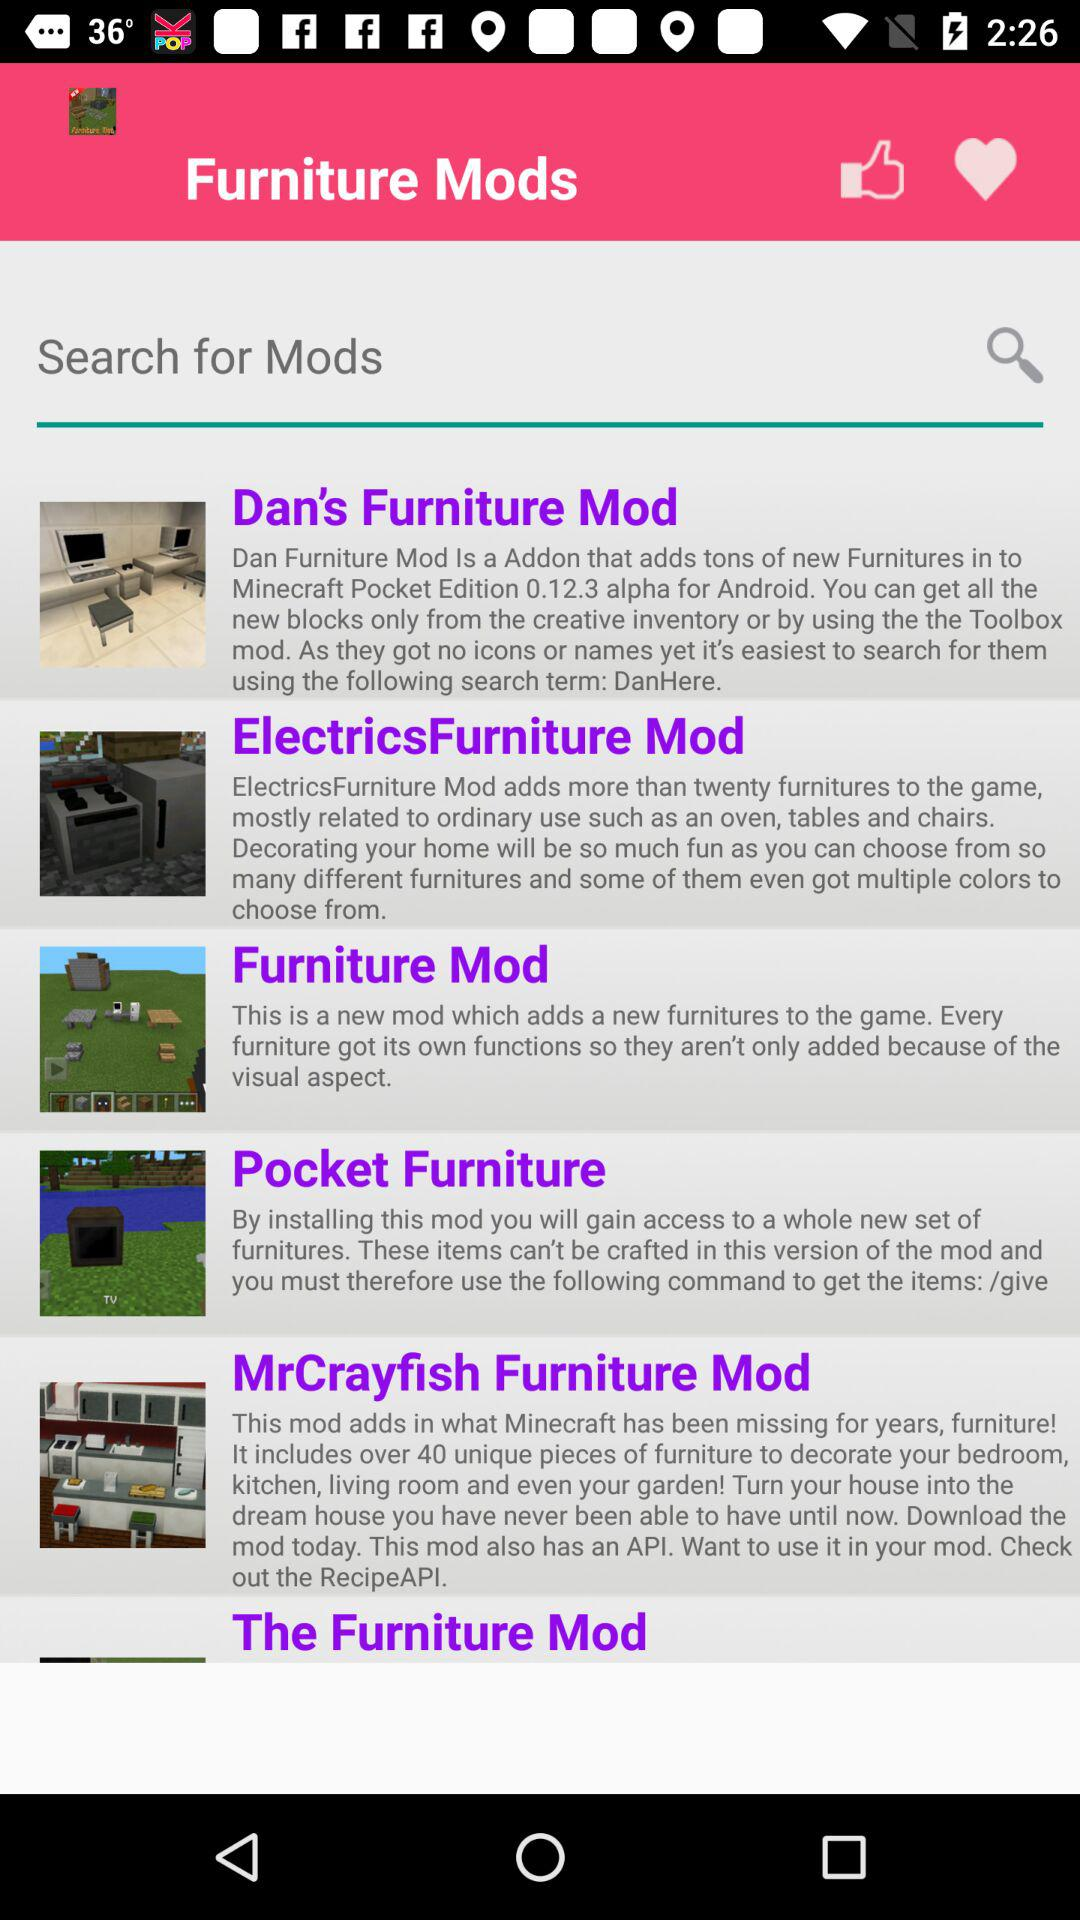How many furniture mods are there?
Answer the question using a single word or phrase. 6 